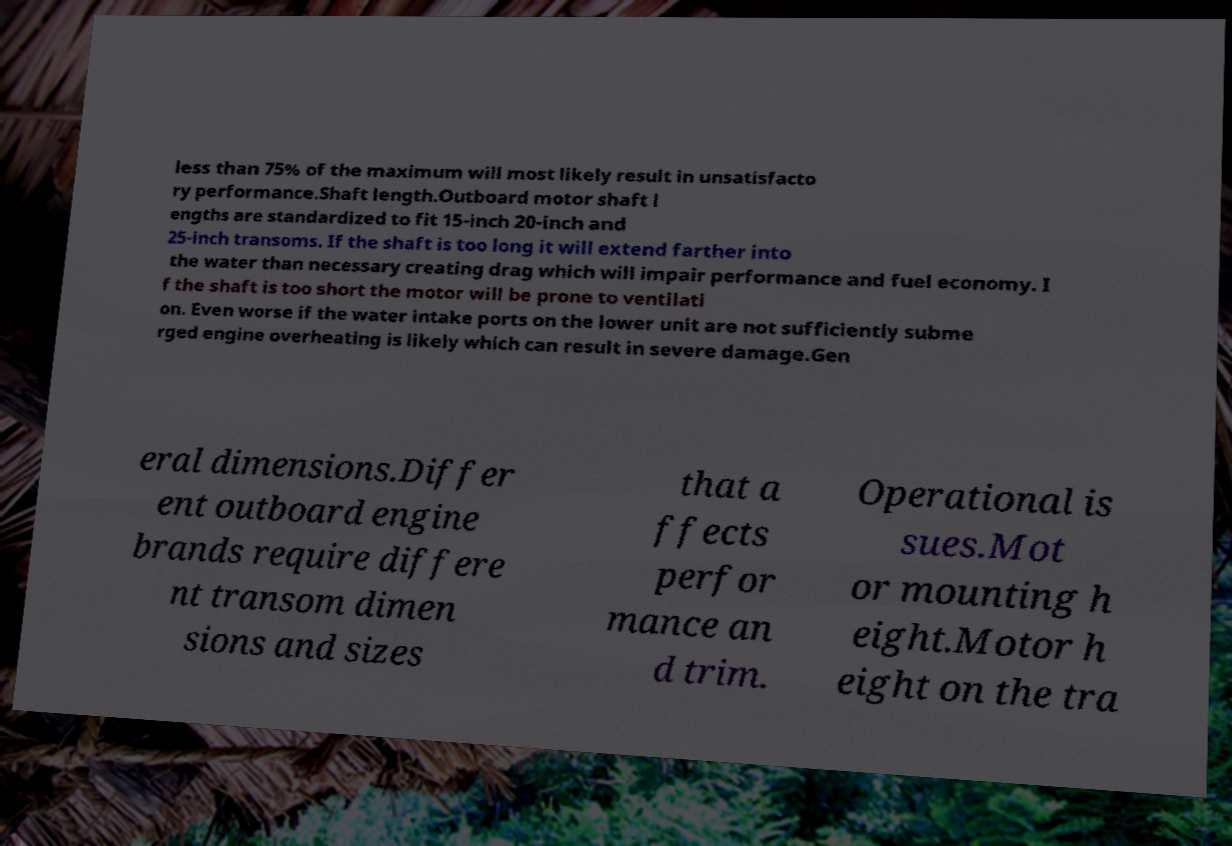Please identify and transcribe the text found in this image. less than 75% of the maximum will most likely result in unsatisfacto ry performance.Shaft length.Outboard motor shaft l engths are standardized to fit 15-inch 20-inch and 25-inch transoms. If the shaft is too long it will extend farther into the water than necessary creating drag which will impair performance and fuel economy. I f the shaft is too short the motor will be prone to ventilati on. Even worse if the water intake ports on the lower unit are not sufficiently subme rged engine overheating is likely which can result in severe damage.Gen eral dimensions.Differ ent outboard engine brands require differe nt transom dimen sions and sizes that a ffects perfor mance an d trim. Operational is sues.Mot or mounting h eight.Motor h eight on the tra 